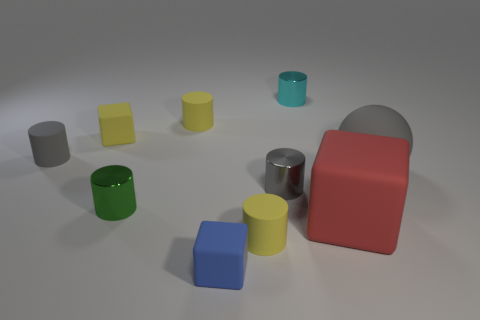How might the arrangement of these objects influence our perception of space in the image? The arrangement of the objects in the image appears intentional, with varying distances between them, creating a sense of depth. This scattered placement might suggest randomness or the concept of free space, allowing the viewer's eye to travel through the scene and explore the relationship between the objects. 